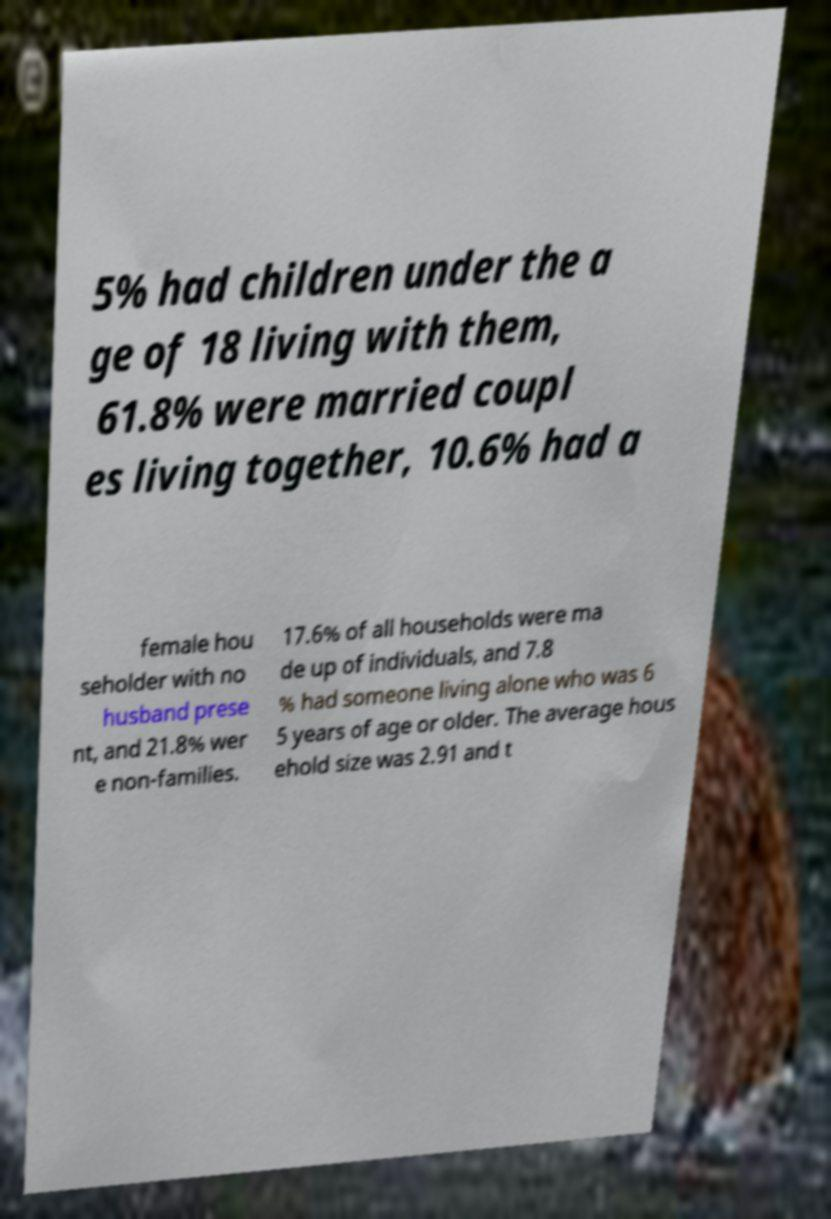Please identify and transcribe the text found in this image. 5% had children under the a ge of 18 living with them, 61.8% were married coupl es living together, 10.6% had a female hou seholder with no husband prese nt, and 21.8% wer e non-families. 17.6% of all households were ma de up of individuals, and 7.8 % had someone living alone who was 6 5 years of age or older. The average hous ehold size was 2.91 and t 